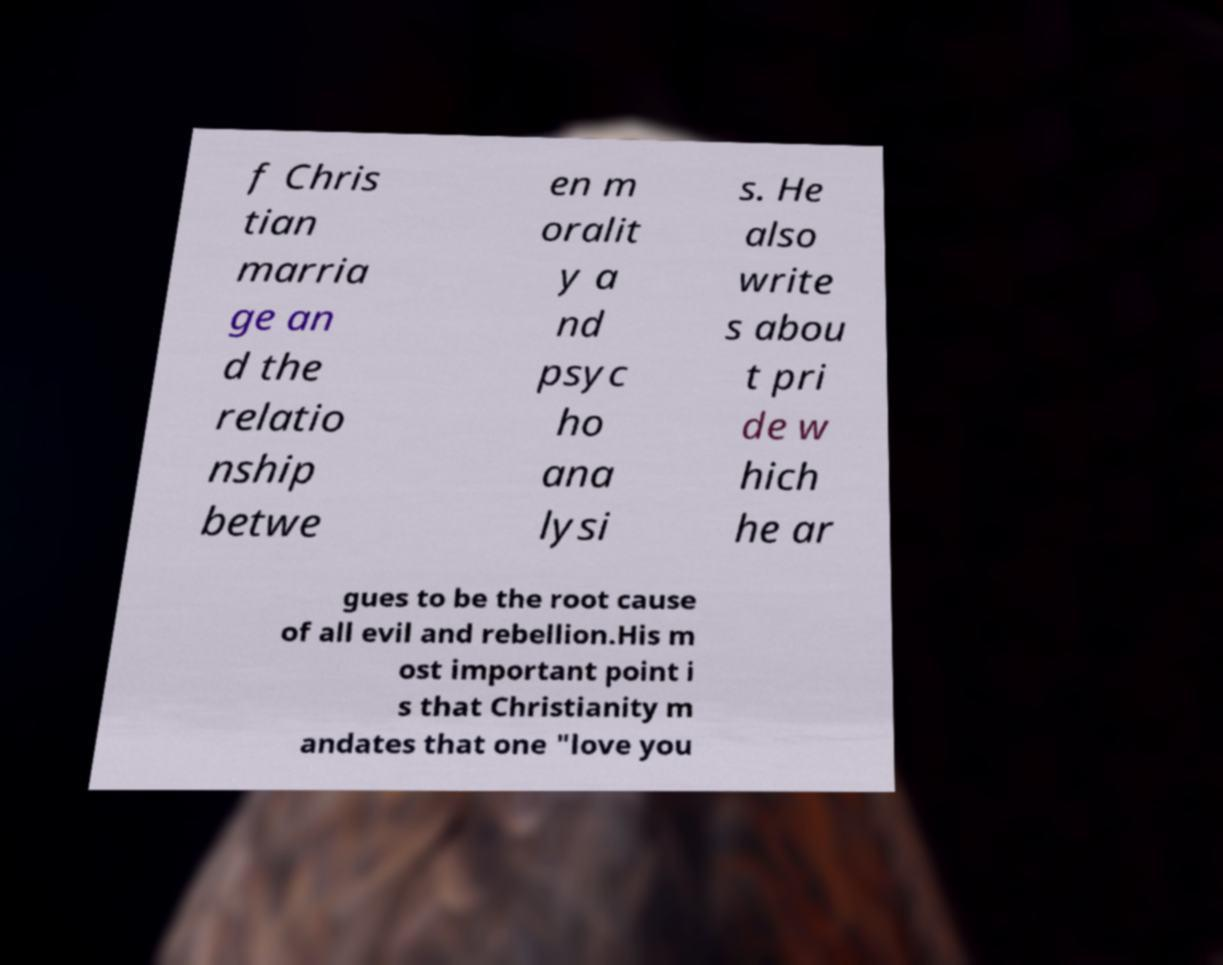Could you extract and type out the text from this image? f Chris tian marria ge an d the relatio nship betwe en m oralit y a nd psyc ho ana lysi s. He also write s abou t pri de w hich he ar gues to be the root cause of all evil and rebellion.His m ost important point i s that Christianity m andates that one "love you 